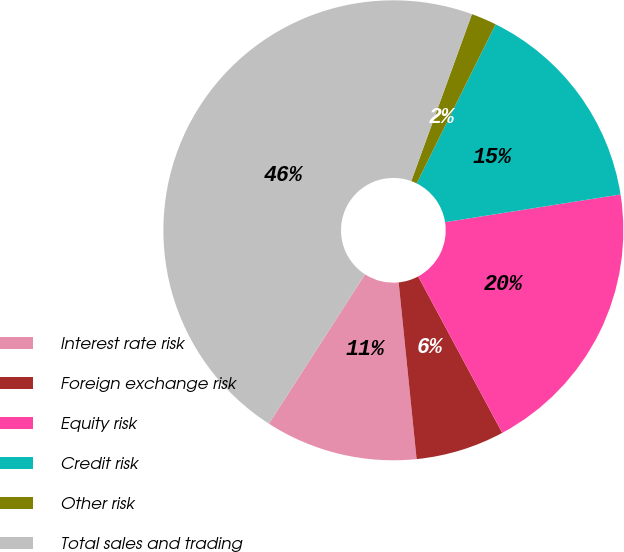Convert chart to OTSL. <chart><loc_0><loc_0><loc_500><loc_500><pie_chart><fcel>Interest rate risk<fcel>Foreign exchange risk<fcel>Equity risk<fcel>Credit risk<fcel>Other risk<fcel>Total sales and trading<nl><fcel>10.71%<fcel>6.24%<fcel>19.64%<fcel>15.18%<fcel>1.78%<fcel>46.45%<nl></chart> 